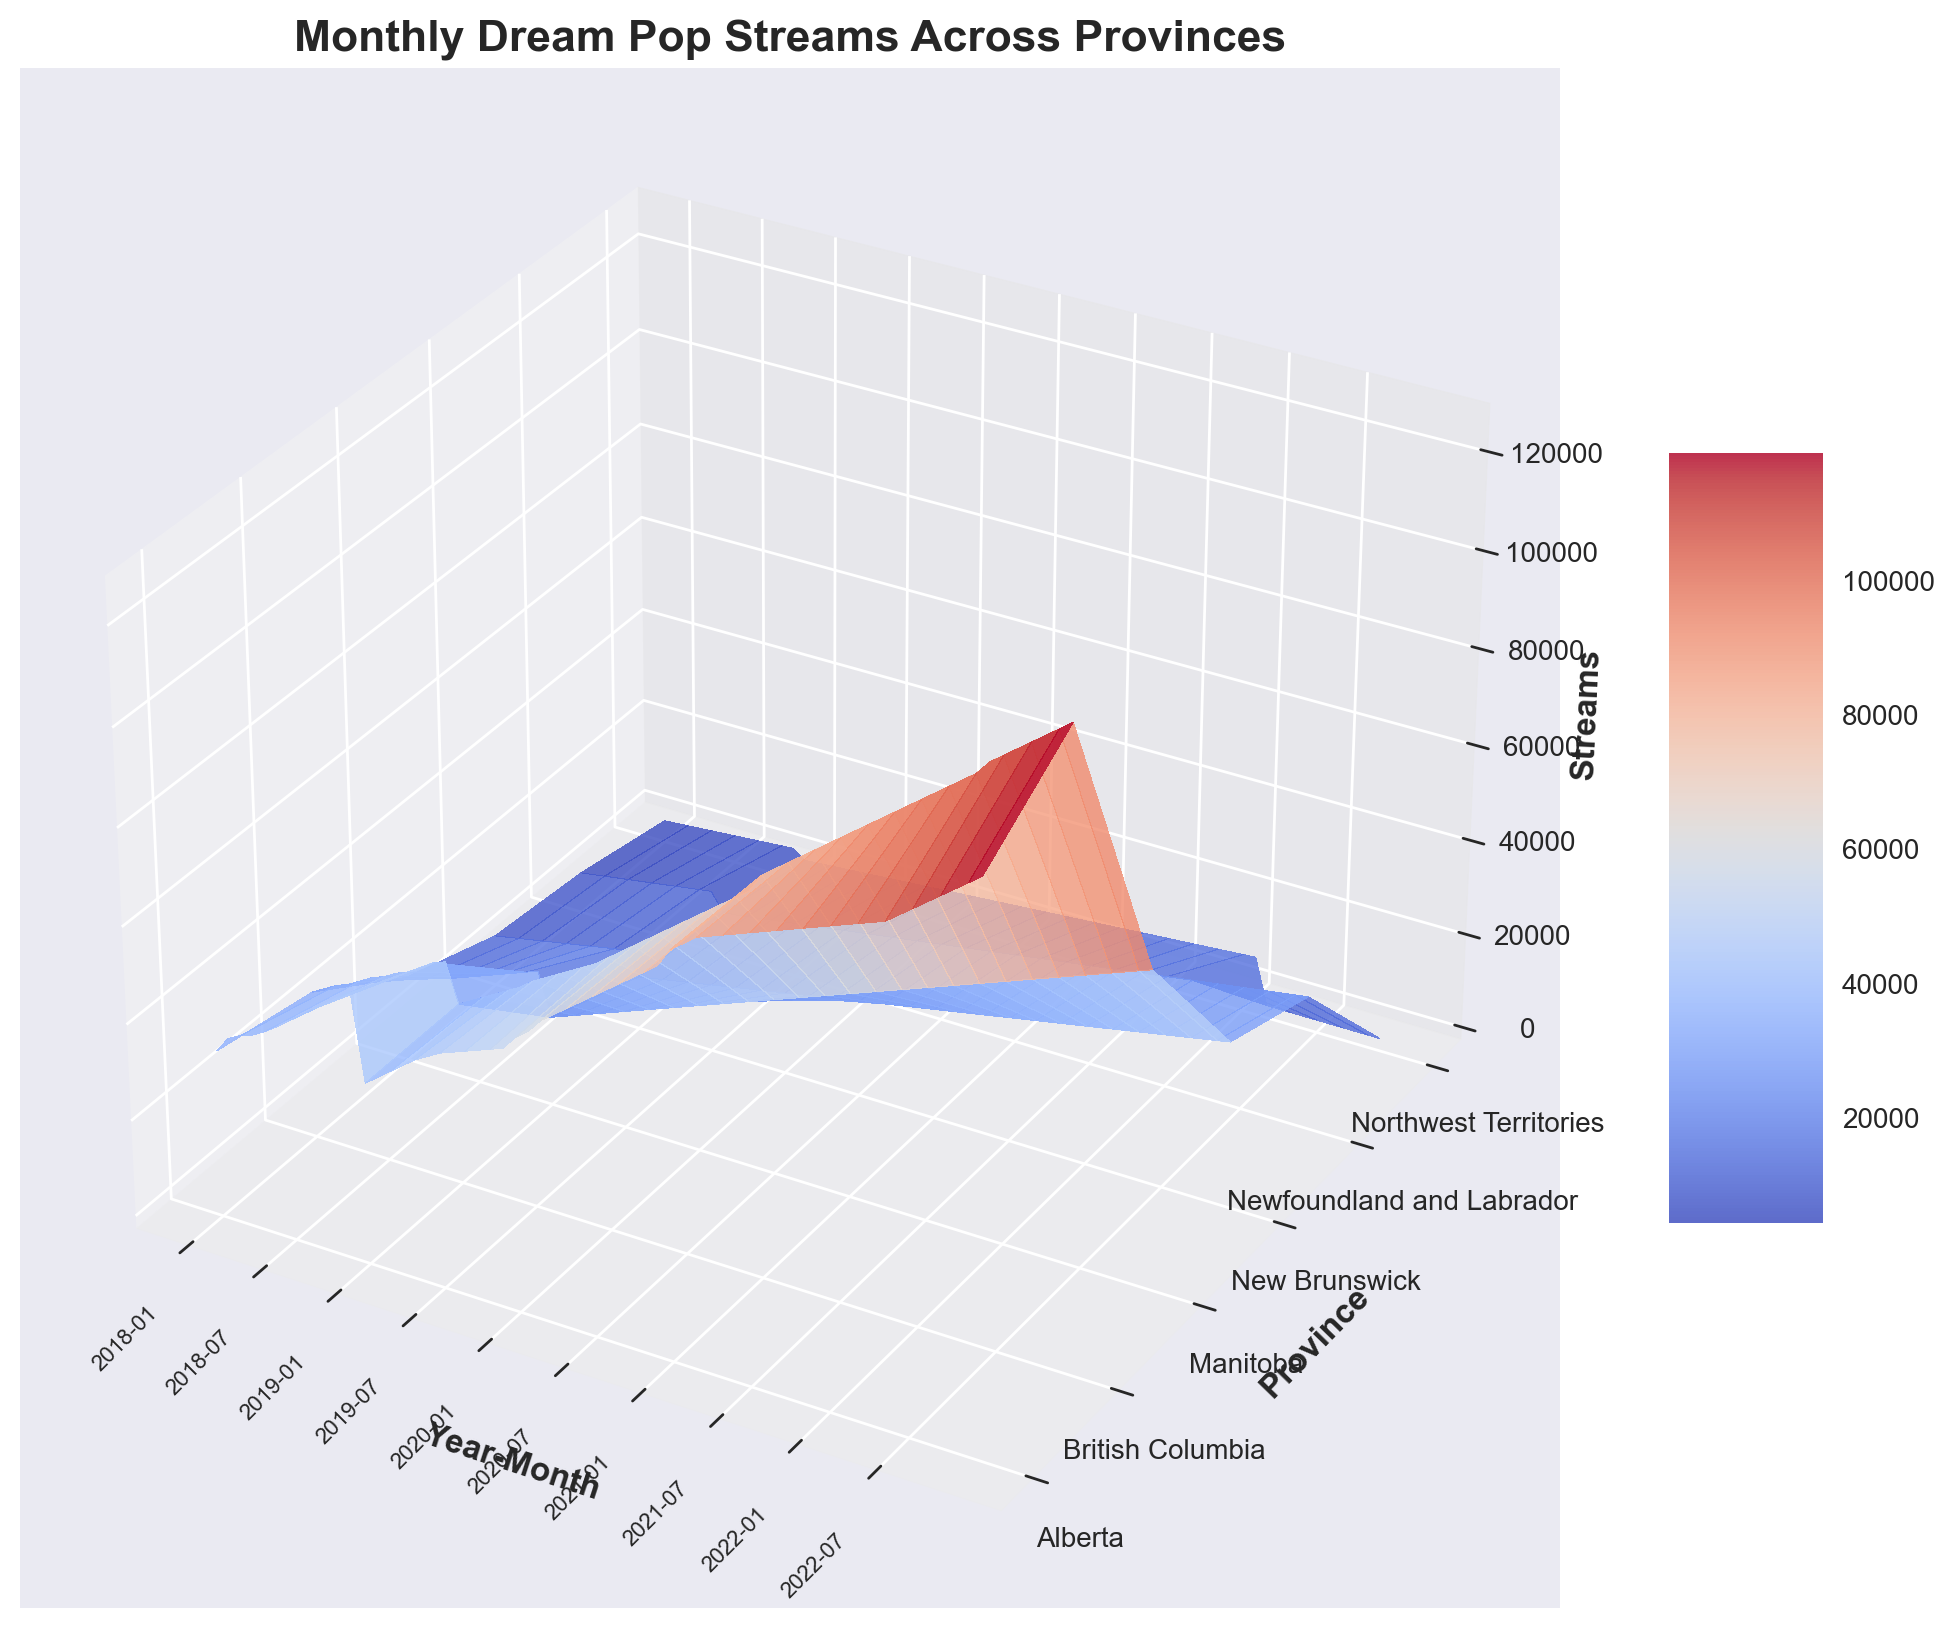Which province had the highest number of streams in December 2022? Look at the z-axis value for December 2022 across all provinces and identify the province with the highest z-value peak.
Answer: British Columbia What was the trend in monthly streams for Alberta from 2018 to 2022? Observe the line of peaks in the z-axis for Alberta from 2018 to 2022. Identify whether the values generally increase, decrease, or stay constant.
Answer: Increasing Which two provinces had the most similar streaming trends over the years? Compare the patterns of peaks and troughs in the z-axis for all the provinces and identify the two provinces with the most similar patterns.
Answer: Manitoba and New Brunswick Did any province experience a significant drop in streams at any point? Scan through the z-axis and look for a noticeable drop in height for any province.
Answer: No significant drop What is the difference in the number of streams between the highest and lowest provinces in January 2021? Compare the peak heights for all provinces in January 2021, find the highest and lowest values, and calculate the difference.
Answer: 72,900 What visual attribute indicates the most popular months for streaming dream pop across all provinces? Look for the highest points on the z-axis, where the surface peaks. These peaks represent the most popular streaming months.
Answer: The color of the peaks (typically a lighter or more intense color) indicates the most popular months Which month in 2020 had the lowest streaming numbers in British Columbia? Look along the z-axis for British Columbia in the year 2020 and identify the month with the smallest peak.
Answer: January How did the streaming numbers for Northwest Territories change from January 2020 to January 2021? Trace the peak heights on the z-axis for Northwest Territories from January 2020 to January 2021 and note the change.
Answer: Increased Compare the streaming trend for Newfoundland and Labrador and Northwest Territories from 2018 to 2022. Observe the patterns of changes in peak heights on the z-axis for both provinces and compare their trends from 2018 to 2022.
Answer: Both trends are increasing, but Newfoundland and Labrador shows a steadier increase Which year had the highest overall streaming numbers for all provinces combined? Integrate all the peak heights for each year and compare the total z-values to determine the year with the highest overall streaming counts.
Answer: 2022 